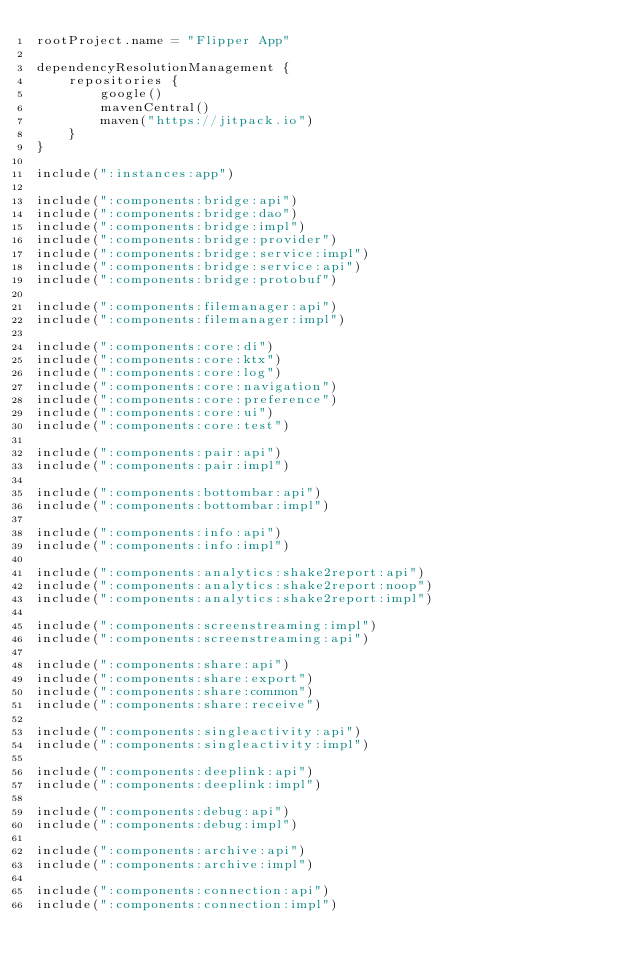Convert code to text. <code><loc_0><loc_0><loc_500><loc_500><_Kotlin_>rootProject.name = "Flipper App"

dependencyResolutionManagement {
    repositories {
        google()
        mavenCentral()
        maven("https://jitpack.io")
    }
}

include(":instances:app")

include(":components:bridge:api")
include(":components:bridge:dao")
include(":components:bridge:impl")
include(":components:bridge:provider")
include(":components:bridge:service:impl")
include(":components:bridge:service:api")
include(":components:bridge:protobuf")

include(":components:filemanager:api")
include(":components:filemanager:impl")

include(":components:core:di")
include(":components:core:ktx")
include(":components:core:log")
include(":components:core:navigation")
include(":components:core:preference")
include(":components:core:ui")
include(":components:core:test")

include(":components:pair:api")
include(":components:pair:impl")

include(":components:bottombar:api")
include(":components:bottombar:impl")

include(":components:info:api")
include(":components:info:impl")

include(":components:analytics:shake2report:api")
include(":components:analytics:shake2report:noop")
include(":components:analytics:shake2report:impl")

include(":components:screenstreaming:impl")
include(":components:screenstreaming:api")

include(":components:share:api")
include(":components:share:export")
include(":components:share:common")
include(":components:share:receive")

include(":components:singleactivity:api")
include(":components:singleactivity:impl")

include(":components:deeplink:api")
include(":components:deeplink:impl")

include(":components:debug:api")
include(":components:debug:impl")

include(":components:archive:api")
include(":components:archive:impl")

include(":components:connection:api")
include(":components:connection:impl")
</code> 